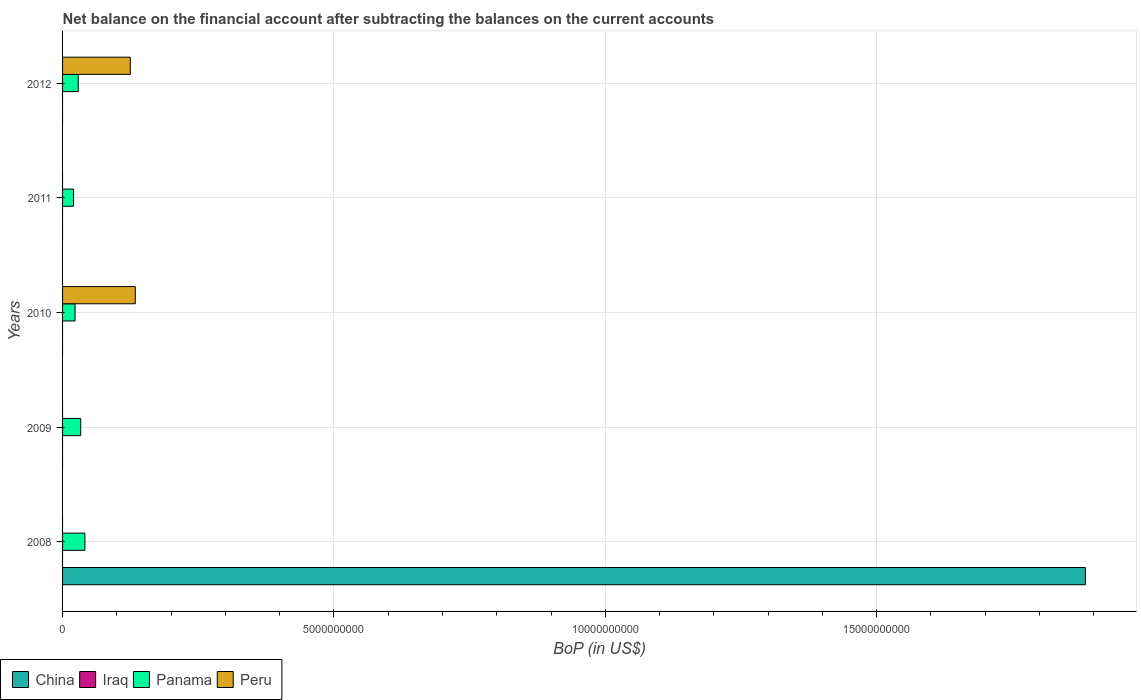How many bars are there on the 5th tick from the top?
Make the answer very short. 2. What is the label of the 2nd group of bars from the top?
Make the answer very short. 2011. What is the Balance of Payments in Panama in 2008?
Your answer should be compact. 4.12e+08. Across all years, what is the maximum Balance of Payments in Peru?
Make the answer very short. 1.34e+09. Across all years, what is the minimum Balance of Payments in Iraq?
Provide a succinct answer. 0. In which year was the Balance of Payments in Panama maximum?
Your answer should be very brief. 2008. What is the total Balance of Payments in Peru in the graph?
Your response must be concise. 2.59e+09. What is the difference between the Balance of Payments in Panama in 2009 and that in 2011?
Make the answer very short. 1.32e+08. What is the difference between the Balance of Payments in China in 2011 and the Balance of Payments in Peru in 2012?
Provide a short and direct response. -1.25e+09. In the year 2010, what is the difference between the Balance of Payments in Peru and Balance of Payments in Panama?
Your answer should be compact. 1.11e+09. What is the ratio of the Balance of Payments in Panama in 2008 to that in 2010?
Offer a very short reply. 1.79. Is the Balance of Payments in Panama in 2009 less than that in 2010?
Make the answer very short. No. Is the difference between the Balance of Payments in Peru in 2010 and 2012 greater than the difference between the Balance of Payments in Panama in 2010 and 2012?
Provide a short and direct response. Yes. What is the difference between the highest and the second highest Balance of Payments in Panama?
Provide a succinct answer. 7.71e+07. What is the difference between the highest and the lowest Balance of Payments in China?
Your response must be concise. 1.88e+1. Is it the case that in every year, the sum of the Balance of Payments in China and Balance of Payments in Peru is greater than the Balance of Payments in Panama?
Give a very brief answer. No. Are all the bars in the graph horizontal?
Provide a short and direct response. Yes. What is the difference between two consecutive major ticks on the X-axis?
Your answer should be very brief. 5.00e+09. Where does the legend appear in the graph?
Give a very brief answer. Bottom left. How many legend labels are there?
Provide a succinct answer. 4. How are the legend labels stacked?
Provide a succinct answer. Horizontal. What is the title of the graph?
Give a very brief answer. Net balance on the financial account after subtracting the balances on the current accounts. What is the label or title of the X-axis?
Your answer should be compact. BoP (in US$). What is the label or title of the Y-axis?
Provide a short and direct response. Years. What is the BoP (in US$) of China in 2008?
Offer a terse response. 1.88e+1. What is the BoP (in US$) of Iraq in 2008?
Keep it short and to the point. 0. What is the BoP (in US$) of Panama in 2008?
Your answer should be very brief. 4.12e+08. What is the BoP (in US$) in Iraq in 2009?
Offer a terse response. 0. What is the BoP (in US$) in Panama in 2009?
Offer a terse response. 3.34e+08. What is the BoP (in US$) of Peru in 2009?
Keep it short and to the point. 0. What is the BoP (in US$) in Iraq in 2010?
Ensure brevity in your answer.  0. What is the BoP (in US$) of Panama in 2010?
Offer a terse response. 2.30e+08. What is the BoP (in US$) in Peru in 2010?
Offer a terse response. 1.34e+09. What is the BoP (in US$) of China in 2011?
Offer a terse response. 0. What is the BoP (in US$) of Iraq in 2011?
Keep it short and to the point. 0. What is the BoP (in US$) in Panama in 2011?
Make the answer very short. 2.02e+08. What is the BoP (in US$) in Panama in 2012?
Make the answer very short. 2.89e+08. What is the BoP (in US$) in Peru in 2012?
Your answer should be very brief. 1.25e+09. Across all years, what is the maximum BoP (in US$) in China?
Give a very brief answer. 1.88e+1. Across all years, what is the maximum BoP (in US$) in Panama?
Offer a very short reply. 4.12e+08. Across all years, what is the maximum BoP (in US$) of Peru?
Give a very brief answer. 1.34e+09. Across all years, what is the minimum BoP (in US$) of China?
Your answer should be very brief. 0. Across all years, what is the minimum BoP (in US$) in Panama?
Offer a terse response. 2.02e+08. What is the total BoP (in US$) of China in the graph?
Offer a very short reply. 1.88e+1. What is the total BoP (in US$) in Iraq in the graph?
Your response must be concise. 0. What is the total BoP (in US$) of Panama in the graph?
Provide a short and direct response. 1.47e+09. What is the total BoP (in US$) of Peru in the graph?
Provide a succinct answer. 2.59e+09. What is the difference between the BoP (in US$) in Panama in 2008 and that in 2009?
Provide a succinct answer. 7.71e+07. What is the difference between the BoP (in US$) in Panama in 2008 and that in 2010?
Provide a succinct answer. 1.82e+08. What is the difference between the BoP (in US$) in Panama in 2008 and that in 2011?
Ensure brevity in your answer.  2.10e+08. What is the difference between the BoP (in US$) in Panama in 2008 and that in 2012?
Give a very brief answer. 1.23e+08. What is the difference between the BoP (in US$) in Panama in 2009 and that in 2010?
Offer a very short reply. 1.04e+08. What is the difference between the BoP (in US$) of Panama in 2009 and that in 2011?
Offer a very short reply. 1.32e+08. What is the difference between the BoP (in US$) in Panama in 2009 and that in 2012?
Offer a very short reply. 4.56e+07. What is the difference between the BoP (in US$) in Panama in 2010 and that in 2011?
Make the answer very short. 2.80e+07. What is the difference between the BoP (in US$) in Panama in 2010 and that in 2012?
Give a very brief answer. -5.88e+07. What is the difference between the BoP (in US$) in Peru in 2010 and that in 2012?
Make the answer very short. 9.18e+07. What is the difference between the BoP (in US$) of Panama in 2011 and that in 2012?
Offer a very short reply. -8.68e+07. What is the difference between the BoP (in US$) in China in 2008 and the BoP (in US$) in Panama in 2009?
Your response must be concise. 1.85e+1. What is the difference between the BoP (in US$) in China in 2008 and the BoP (in US$) in Panama in 2010?
Your response must be concise. 1.86e+1. What is the difference between the BoP (in US$) of China in 2008 and the BoP (in US$) of Peru in 2010?
Keep it short and to the point. 1.75e+1. What is the difference between the BoP (in US$) in Panama in 2008 and the BoP (in US$) in Peru in 2010?
Provide a short and direct response. -9.28e+08. What is the difference between the BoP (in US$) of China in 2008 and the BoP (in US$) of Panama in 2011?
Your answer should be very brief. 1.86e+1. What is the difference between the BoP (in US$) in China in 2008 and the BoP (in US$) in Panama in 2012?
Offer a very short reply. 1.86e+1. What is the difference between the BoP (in US$) in China in 2008 and the BoP (in US$) in Peru in 2012?
Provide a short and direct response. 1.76e+1. What is the difference between the BoP (in US$) in Panama in 2008 and the BoP (in US$) in Peru in 2012?
Offer a terse response. -8.36e+08. What is the difference between the BoP (in US$) of Panama in 2009 and the BoP (in US$) of Peru in 2010?
Offer a very short reply. -1.01e+09. What is the difference between the BoP (in US$) in Panama in 2009 and the BoP (in US$) in Peru in 2012?
Make the answer very short. -9.13e+08. What is the difference between the BoP (in US$) of Panama in 2010 and the BoP (in US$) of Peru in 2012?
Offer a terse response. -1.02e+09. What is the difference between the BoP (in US$) in Panama in 2011 and the BoP (in US$) in Peru in 2012?
Your answer should be compact. -1.05e+09. What is the average BoP (in US$) in China per year?
Offer a terse response. 3.77e+09. What is the average BoP (in US$) in Panama per year?
Ensure brevity in your answer.  2.93e+08. What is the average BoP (in US$) of Peru per year?
Provide a succinct answer. 5.18e+08. In the year 2008, what is the difference between the BoP (in US$) in China and BoP (in US$) in Panama?
Keep it short and to the point. 1.84e+1. In the year 2010, what is the difference between the BoP (in US$) in Panama and BoP (in US$) in Peru?
Offer a terse response. -1.11e+09. In the year 2012, what is the difference between the BoP (in US$) in Panama and BoP (in US$) in Peru?
Your response must be concise. -9.59e+08. What is the ratio of the BoP (in US$) of Panama in 2008 to that in 2009?
Make the answer very short. 1.23. What is the ratio of the BoP (in US$) in Panama in 2008 to that in 2010?
Offer a very short reply. 1.79. What is the ratio of the BoP (in US$) of Panama in 2008 to that in 2011?
Offer a terse response. 2.04. What is the ratio of the BoP (in US$) of Panama in 2008 to that in 2012?
Provide a succinct answer. 1.42. What is the ratio of the BoP (in US$) of Panama in 2009 to that in 2010?
Offer a terse response. 1.45. What is the ratio of the BoP (in US$) of Panama in 2009 to that in 2011?
Offer a terse response. 1.66. What is the ratio of the BoP (in US$) in Panama in 2009 to that in 2012?
Your response must be concise. 1.16. What is the ratio of the BoP (in US$) of Panama in 2010 to that in 2011?
Provide a succinct answer. 1.14. What is the ratio of the BoP (in US$) in Panama in 2010 to that in 2012?
Keep it short and to the point. 0.8. What is the ratio of the BoP (in US$) in Peru in 2010 to that in 2012?
Ensure brevity in your answer.  1.07. What is the ratio of the BoP (in US$) of Panama in 2011 to that in 2012?
Keep it short and to the point. 0.7. What is the difference between the highest and the second highest BoP (in US$) of Panama?
Keep it short and to the point. 7.71e+07. What is the difference between the highest and the lowest BoP (in US$) of China?
Provide a succinct answer. 1.88e+1. What is the difference between the highest and the lowest BoP (in US$) of Panama?
Provide a succinct answer. 2.10e+08. What is the difference between the highest and the lowest BoP (in US$) of Peru?
Provide a succinct answer. 1.34e+09. 